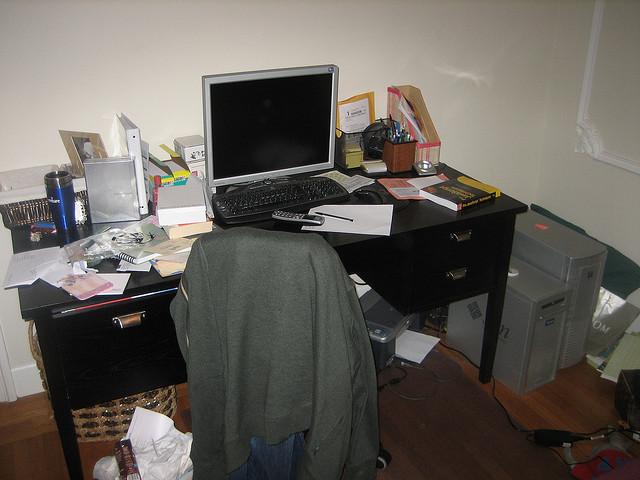Is the monitor on?
Give a very brief answer. No. What color is the bag on the left?
Keep it brief. White. Is the computer screen on?
Concise answer only. No. Is the desk cluttered?
Give a very brief answer. Yes. How many computer towers are in the picture?
Be succinct. 2. Are there books on the table?
Be succinct. Yes. 